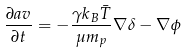<formula> <loc_0><loc_0><loc_500><loc_500>\frac { \partial a { v } } { \partial t } = - \frac { \gamma k _ { B } \bar { T } } { \mu m _ { p } } \nabla \delta - \nabla \phi</formula> 